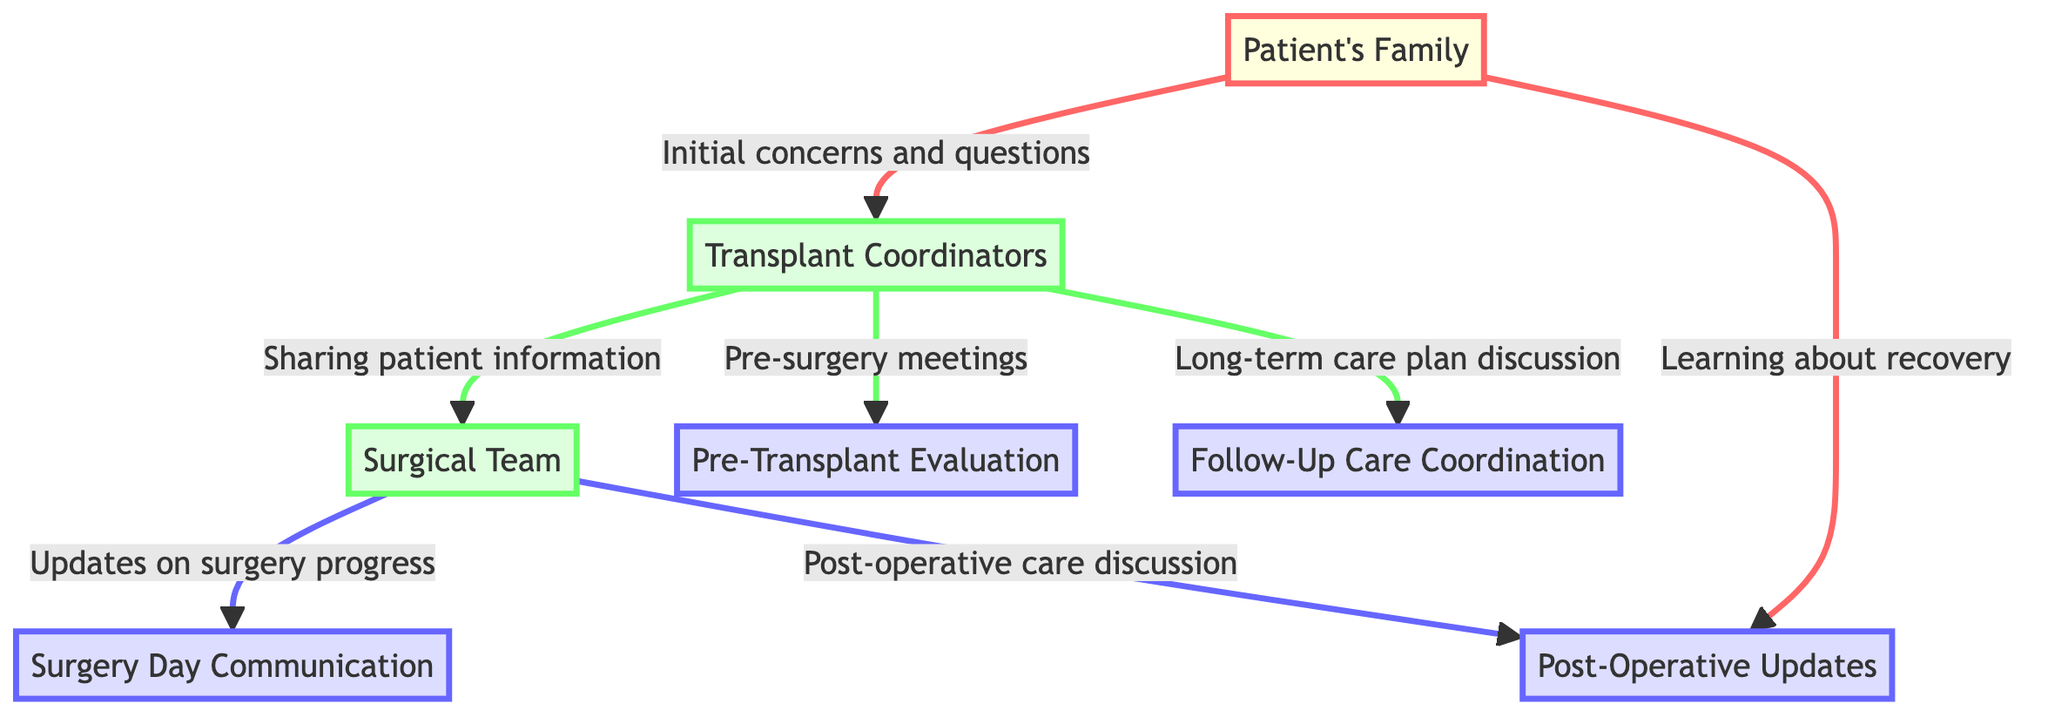What is the total number of nodes in the diagram? The diagram contains seven distinct entities which represent different parts of the communication process, namely the Patient's Family, Transplant Coordinators, Surgical Team, Pre-Transplant Evaluation, Surgery Day Communication, Post-Operative Updates, and Follow-Up Care Coordination. Therefore, counting these gives a total of seven nodes.
Answer: 7 Which two groups communicate during pre-surgery meetings? The pre-surgery meetings are explicitly represented in the diagram as a directed edge from the Transplant Coordinators to the Pre-Transplant Evaluation. This indicates that the groups involved in this communication are the Transplant Coordinators and the Surgical Team.
Answer: Transplant Coordinators and Surgical Team What type of information is shared from the Transplant Coordinators to the Surgical Team? The edge connecting the Transplant Coordinators to the Surgical Team is labeled "Sharing patient information," indicating that this type of information is exchanged. Thus, the information shared in this communication is patient-related.
Answer: Sharing patient information What type of updates do the Surgical Team provide on surgery day? The edge from the Surgical Team to Surgery Day Communication is labeled "Updates on surgery progress," which clearly indicates the nature of updates provided by the Surgical Team on the day of the surgery.
Answer: Updates on surgery progress Which node has connections to both the Patient's Family and the Surgical Team? Analyzing the diagram, I see that the Post-Operative Updates node has directed connections from the Patient's Family as well as from the Surgical Team. Thus, this node serves as a point of communication between both groups.
Answer: Post-Operative Updates What is the last stage in the communication process depicted in the diagram? By reviewing the edges in the diagram, the last node identified in terms of communication is Follow-Up Care Coordination, as it represents a long-term care plan discussion stemming from the Transplant Coordinators. This implies it’s the concluding phase of the communication process.
Answer: Follow-Up Care Coordination How many edges originate from the Transplant Coordinators? Upon inspection of the diagram, there are three directed edges originating from the Transplant Coordinators going to Pre-Transplant Evaluation, the Surgical Team, and Follow-Up Care Coordination. This indicates that the Transplant Coordinators play a central role in the communication network.
Answer: 3 What communication occurs directly between the Patient's Family and the Post-Operative Updates? The edge from the Patient's Family to Post-Operative Updates is labeled "Learning about recovery," signifying that this communication is focused on educating the family about the patient's recovery process following surgery.
Answer: Learning about recovery 